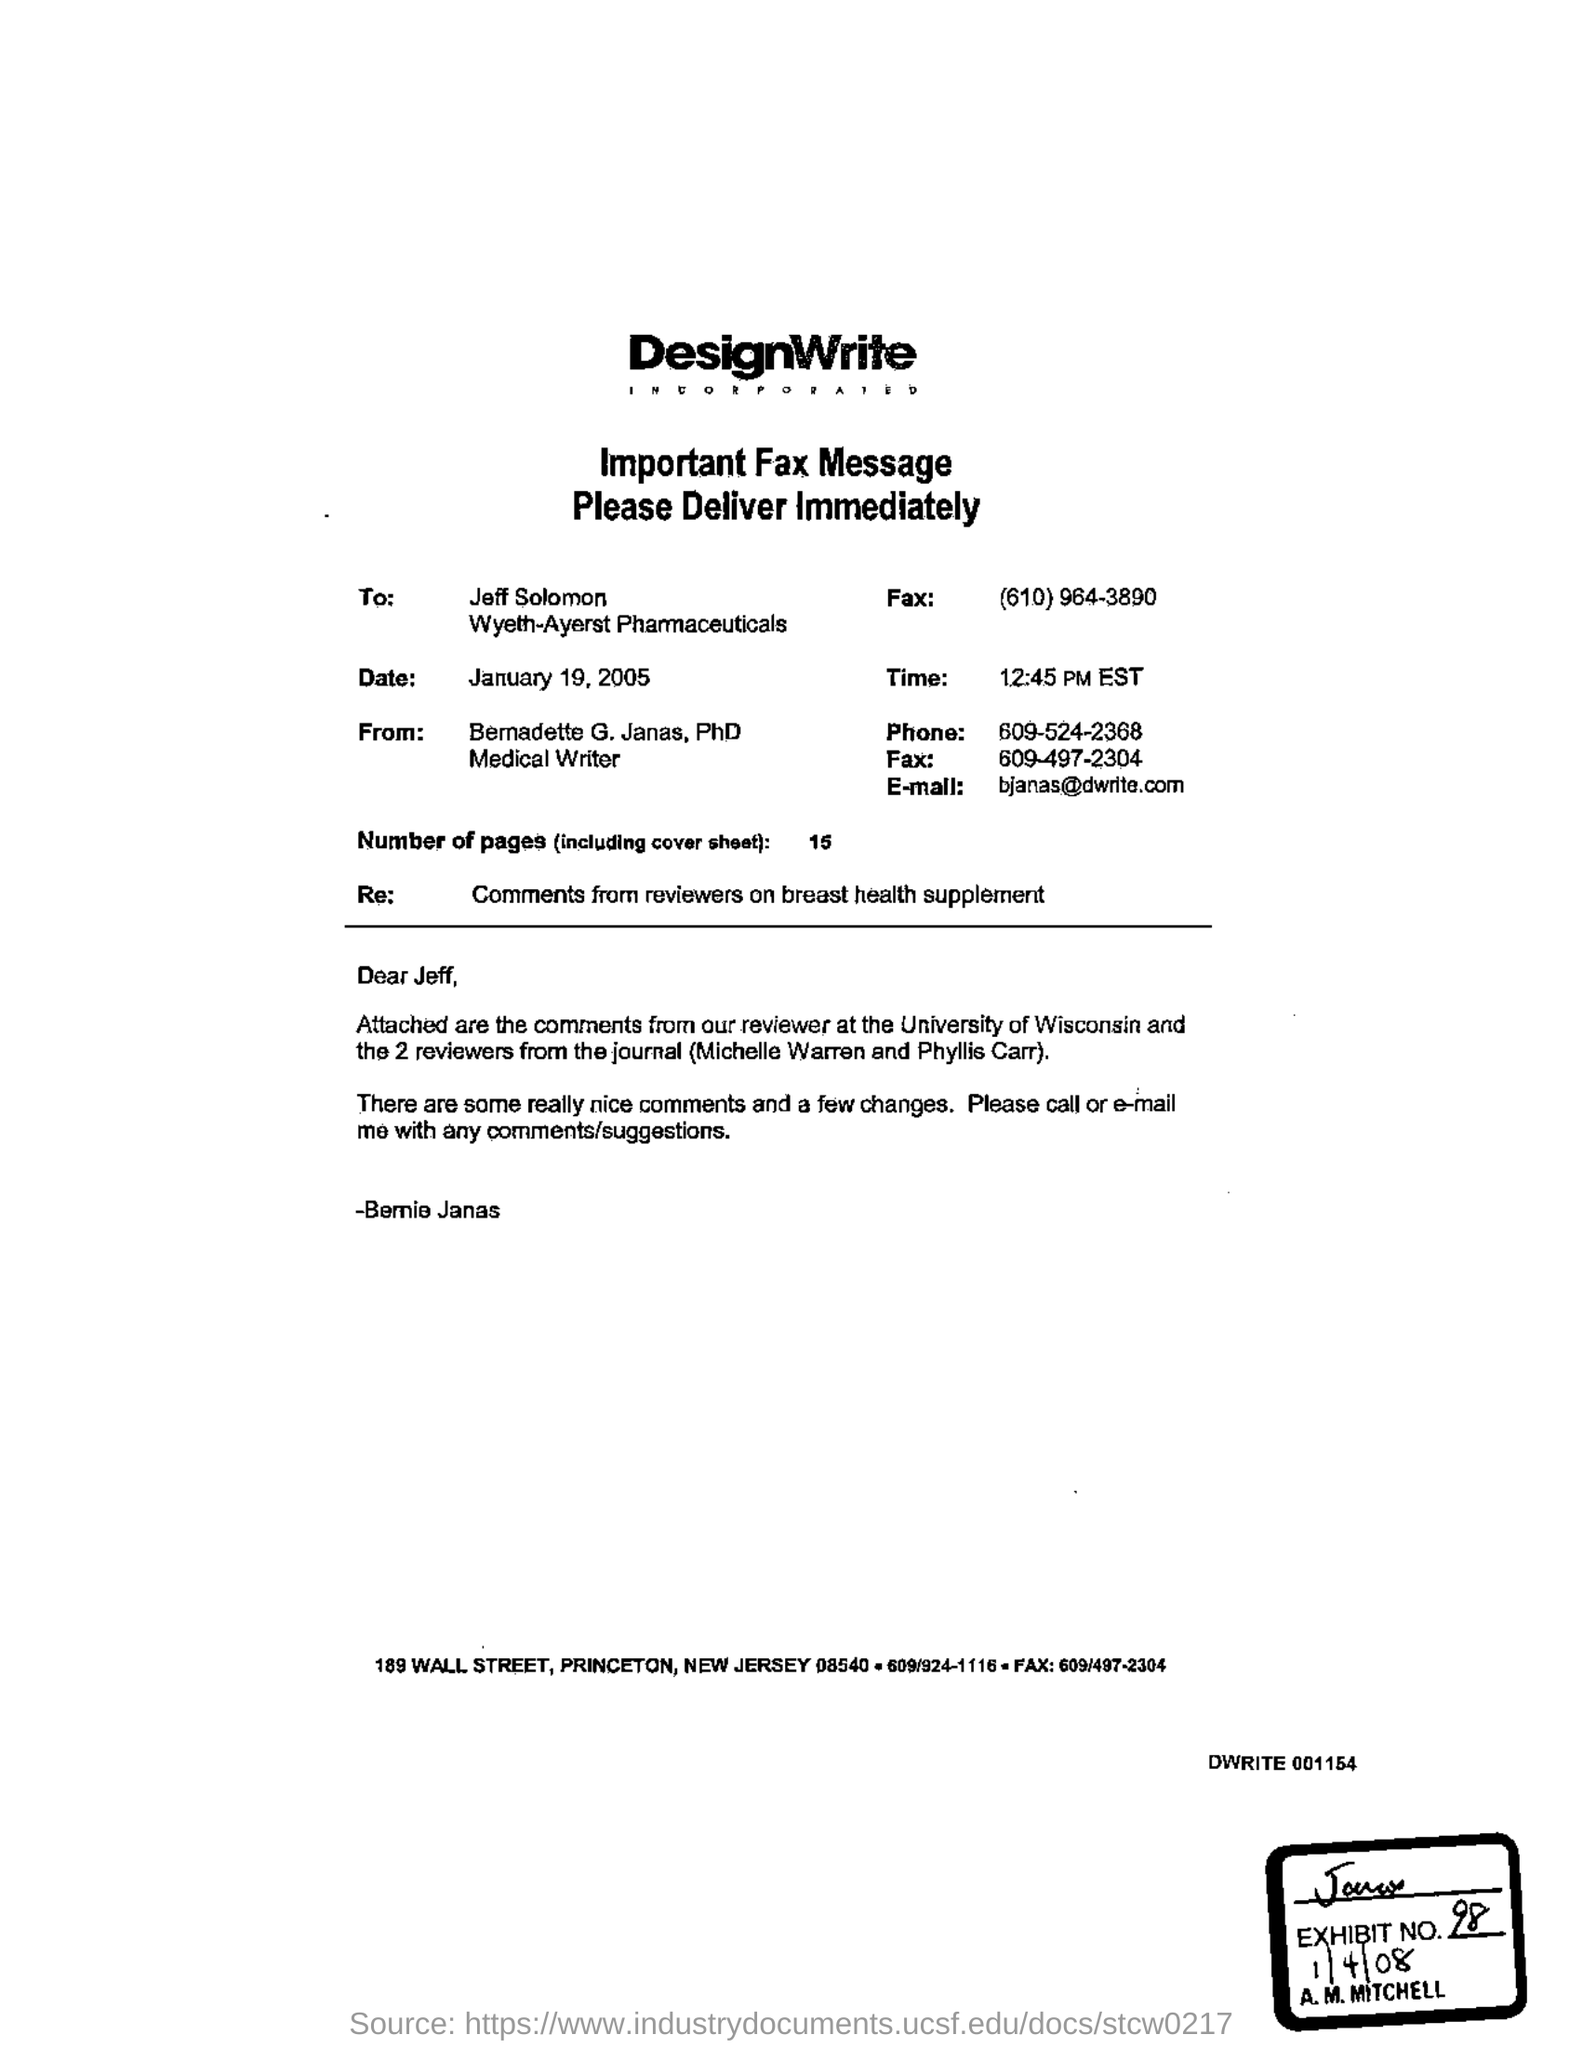What is the time?
Provide a short and direct response. 12:45 pm est. What is the number of pages?
Offer a terse response. 15. What is the salutation of this letter?
Your answer should be compact. Dear jeff. What is the E- mail address?
Offer a terse response. Bjanas@dwrite.com. 